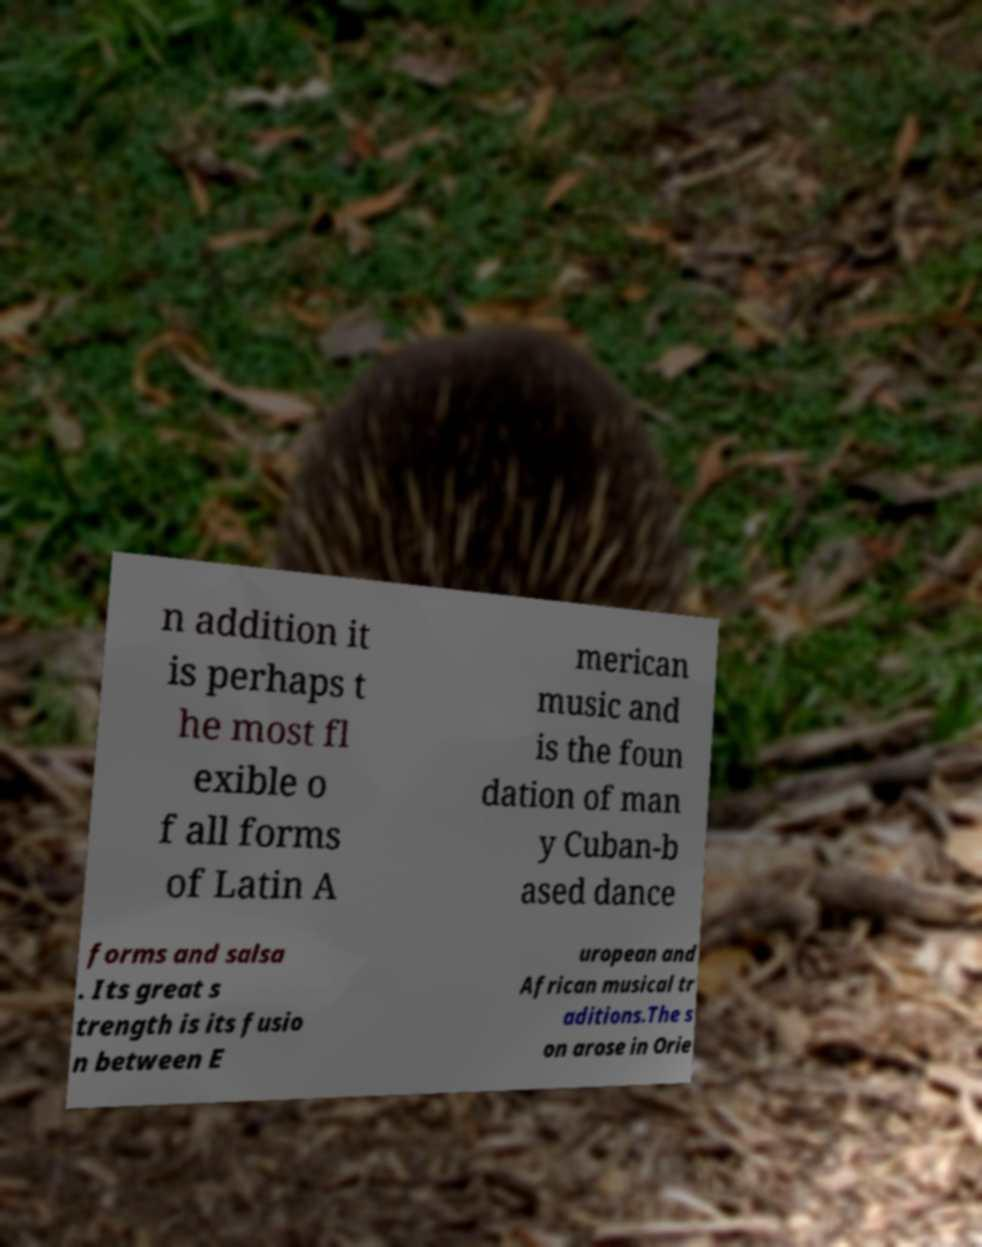Please read and relay the text visible in this image. What does it say? n addition it is perhaps t he most fl exible o f all forms of Latin A merican music and is the foun dation of man y Cuban-b ased dance forms and salsa . Its great s trength is its fusio n between E uropean and African musical tr aditions.The s on arose in Orie 